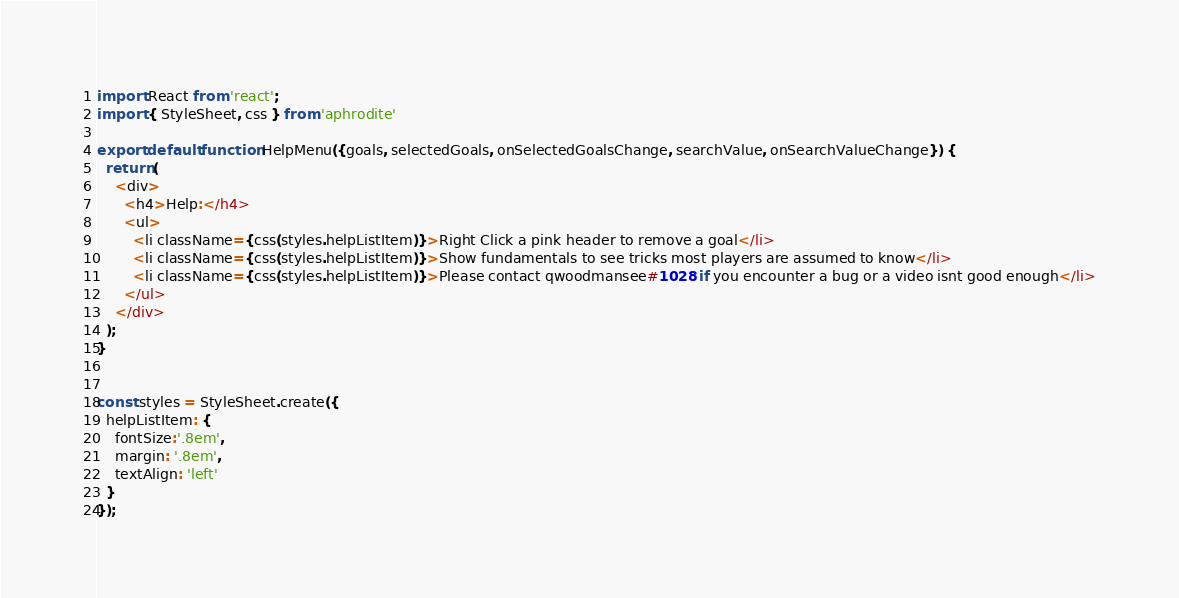Convert code to text. <code><loc_0><loc_0><loc_500><loc_500><_JavaScript_>import React from 'react';
import { StyleSheet, css } from 'aphrodite'

export default function HelpMenu({goals, selectedGoals, onSelectedGoalsChange, searchValue, onSearchValueChange}) {
  return (
    <div>
      <h4>Help:</h4>
      <ul>
        <li className={css(styles.helpListItem)}>Right Click a pink header to remove a goal</li>
        <li className={css(styles.helpListItem)}>Show fundamentals to see tricks most players are assumed to know</li>
        <li className={css(styles.helpListItem)}>Please contact qwoodmansee#1028 if you encounter a bug or a video isnt good enough</li>
      </ul>
    </div>
  );
}


const styles = StyleSheet.create({
  helpListItem: {
    fontSize:'.8em',
    margin: '.8em',
    textAlign: 'left'
  }
});</code> 